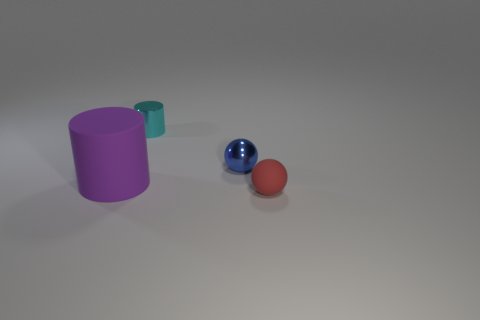Add 1 large cyan spheres. How many objects exist? 5 Add 1 tiny rubber balls. How many tiny rubber balls exist? 2 Subtract 0 gray cubes. How many objects are left? 4 Subtract all large green matte cylinders. Subtract all purple objects. How many objects are left? 3 Add 4 small shiny cylinders. How many small shiny cylinders are left? 5 